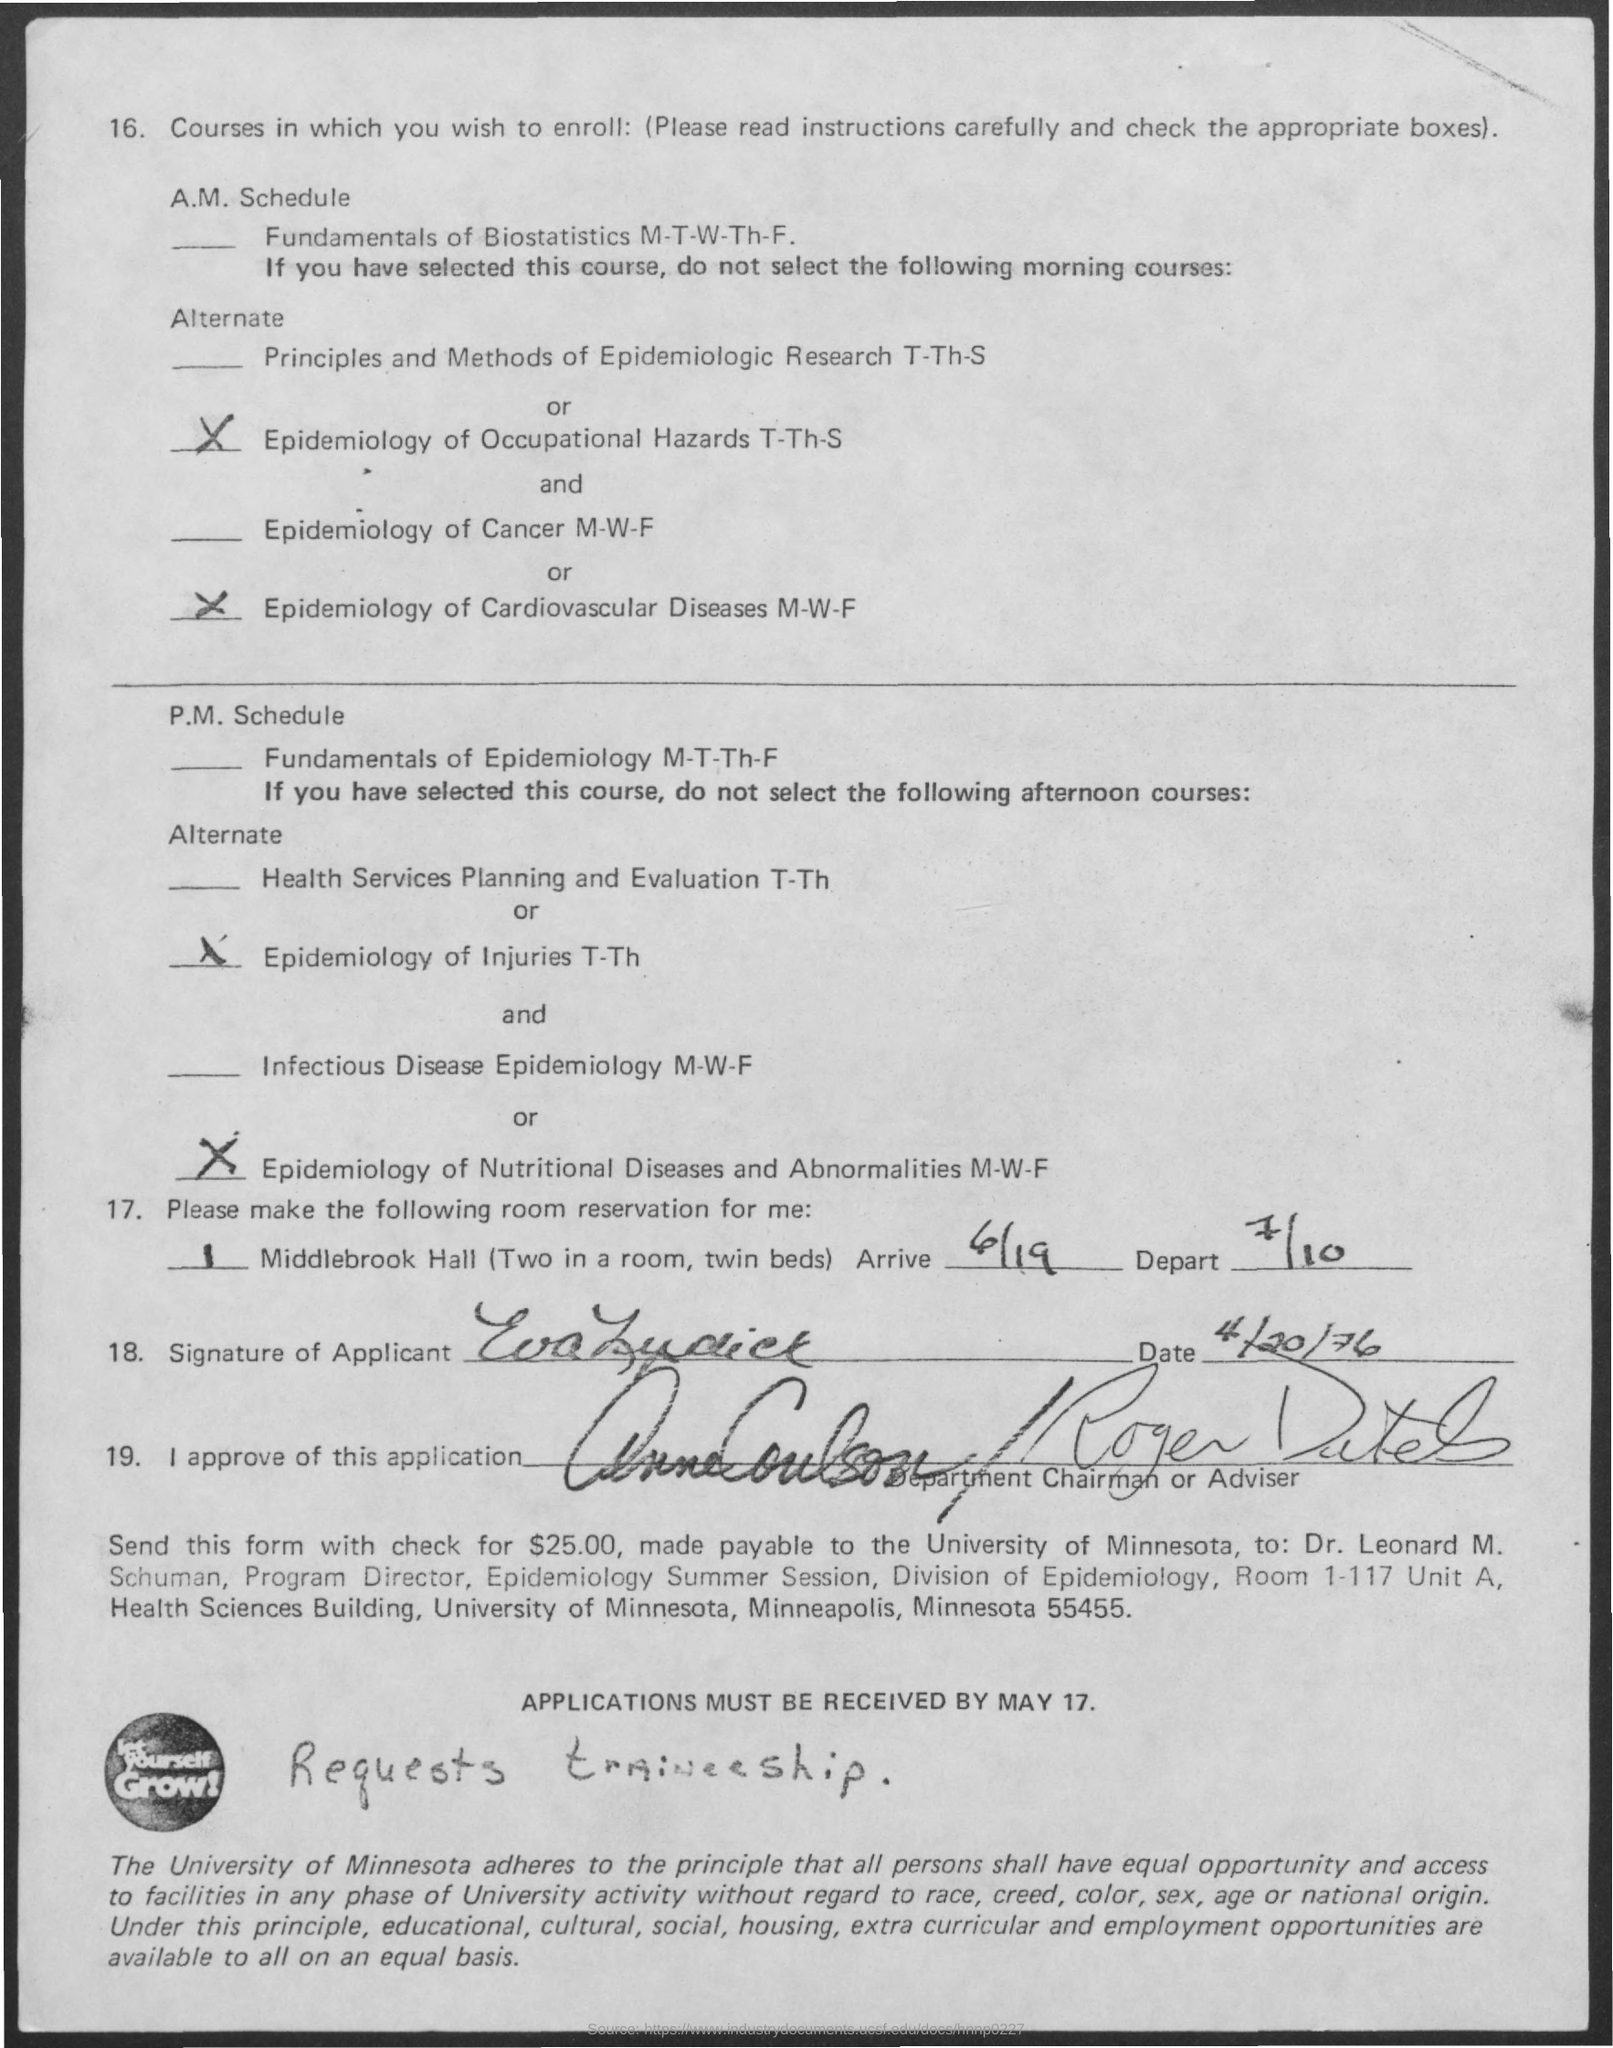Give some essential details in this illustration. The date for the word 'arrive' is 6/19. On or before May 17, the application should be received. The date on the application is April 20, 1976. Please provide the date for departure on July 10. 